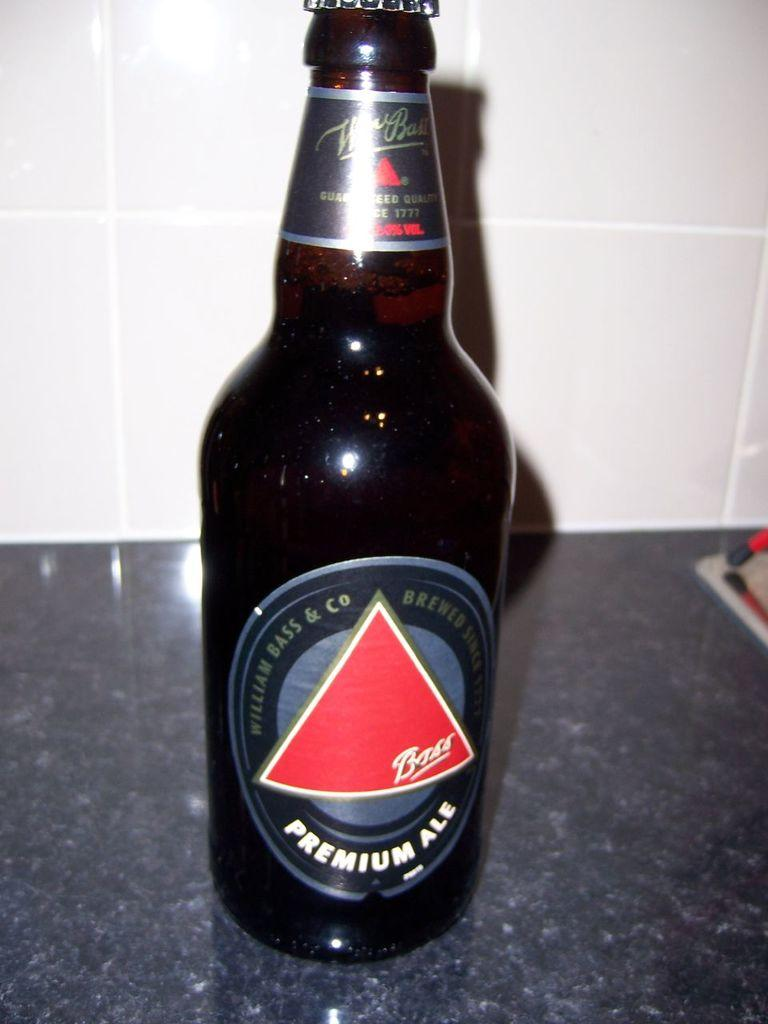<image>
Render a clear and concise summary of the photo. A bottle of Bass Premium Ale sits on a granite countertop 